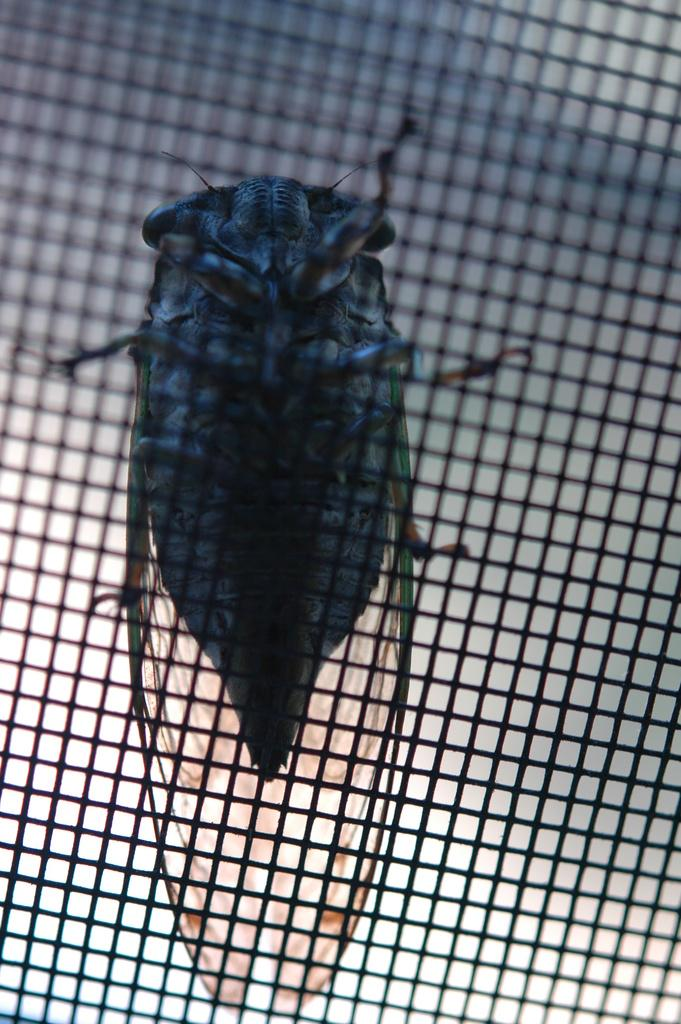What type of insect is present in the image? There is a house fly in the image. What is the house fly standing on? The house fly is standing on a net. What type of flowers are in the vase on the table in the image? There is no vase or table present in the image; it only features a house fly standing on a net. 